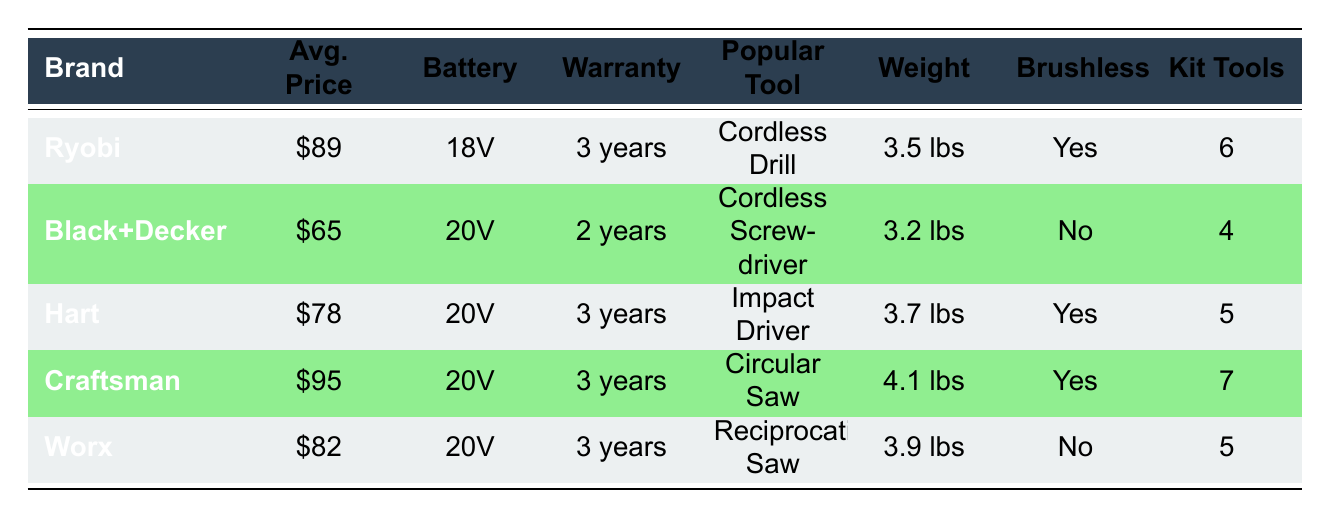What is the average price of the listed power tool brands? To find the average price, we need to sum the individual average prices of all brands: 89 + 65 + 78 + 95 + 82 = 409. Then we divide the total by the number of brands, which is 5. Thus, the average price is 409/5 = 81.8, which we can round to 82.
Answer: 82 Which brand has the heaviest tool? By examining the weights of all brands listed, we see that Craftsman has the highest weight at 4.1 lbs compared to others. Therefore, Craftsman is the brand with the heaviest tool.
Answer: Craftsman Is Ryobi's warranty longer than Black+Decker's? Ryobi has a warranty of 3 years, while Black+Decker offers a warranty of 2 years. Since 3 years is greater than 2 years, Ryobi's warranty is indeed longer than Black+Decker's.
Answer: Yes How many brands offer brushless motors? By checking the table, we note that Ryobi, Hart, and Craftsman have brushless motors. Thus, a total of 3 brands offer brushless motors.
Answer: 3 Which brand has the most tools in its combo kit? Looking at the number of tools in the combo kits, Craftsman has 7 tools, which is more than any other brand listed. Thus, Craftsman has the most tools in its combo kit.
Answer: Craftsman What is the total weight of all tools from the brands listed? To calculate the total weight, we sum the weights of all brands: 3.5 + 3.2 + 3.7 + 4.1 + 3.9 = 18.4 lbs. Hence, the total weight of all tools from the brands listed is 18.4 lbs.
Answer: 18.4 lbs Does Worx have a brushless motor? According to the table, Worx does not feature a brushless motor since it is marked 'No.' Thus, the answer is straightforward from the data.
Answer: No Which brands have a battery voltage of 20V? From the table, Black+Decker, Hart, Craftsman, and Worx all list a battery voltage of 20V. Therefore, four brands have this battery voltage.
Answer: 4 